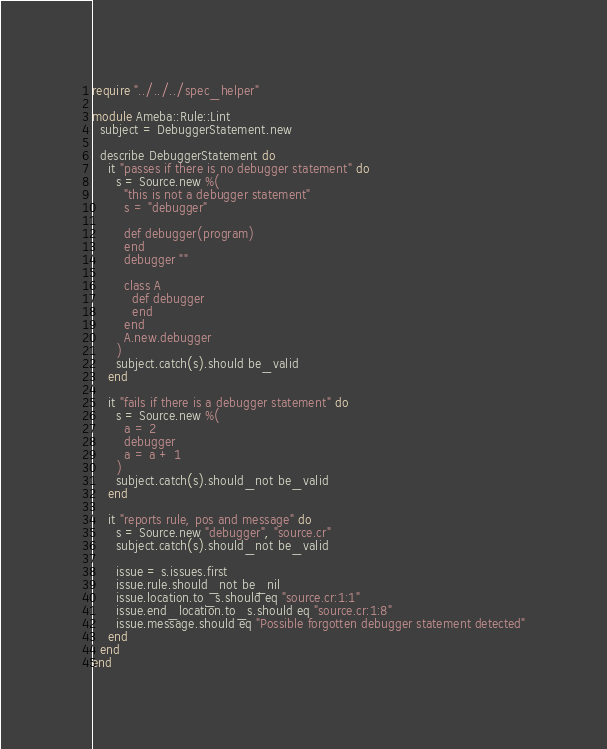Convert code to text. <code><loc_0><loc_0><loc_500><loc_500><_Crystal_>require "../../../spec_helper"

module Ameba::Rule::Lint
  subject = DebuggerStatement.new

  describe DebuggerStatement do
    it "passes if there is no debugger statement" do
      s = Source.new %(
        "this is not a debugger statement"
        s = "debugger"

        def debugger(program)
        end
        debugger ""

        class A
          def debugger
          end
        end
        A.new.debugger
      )
      subject.catch(s).should be_valid
    end

    it "fails if there is a debugger statement" do
      s = Source.new %(
        a = 2
        debugger
        a = a + 1
      )
      subject.catch(s).should_not be_valid
    end

    it "reports rule, pos and message" do
      s = Source.new "debugger", "source.cr"
      subject.catch(s).should_not be_valid

      issue = s.issues.first
      issue.rule.should_not be_nil
      issue.location.to_s.should eq "source.cr:1:1"
      issue.end_location.to_s.should eq "source.cr:1:8"
      issue.message.should eq "Possible forgotten debugger statement detected"
    end
  end
end
</code> 